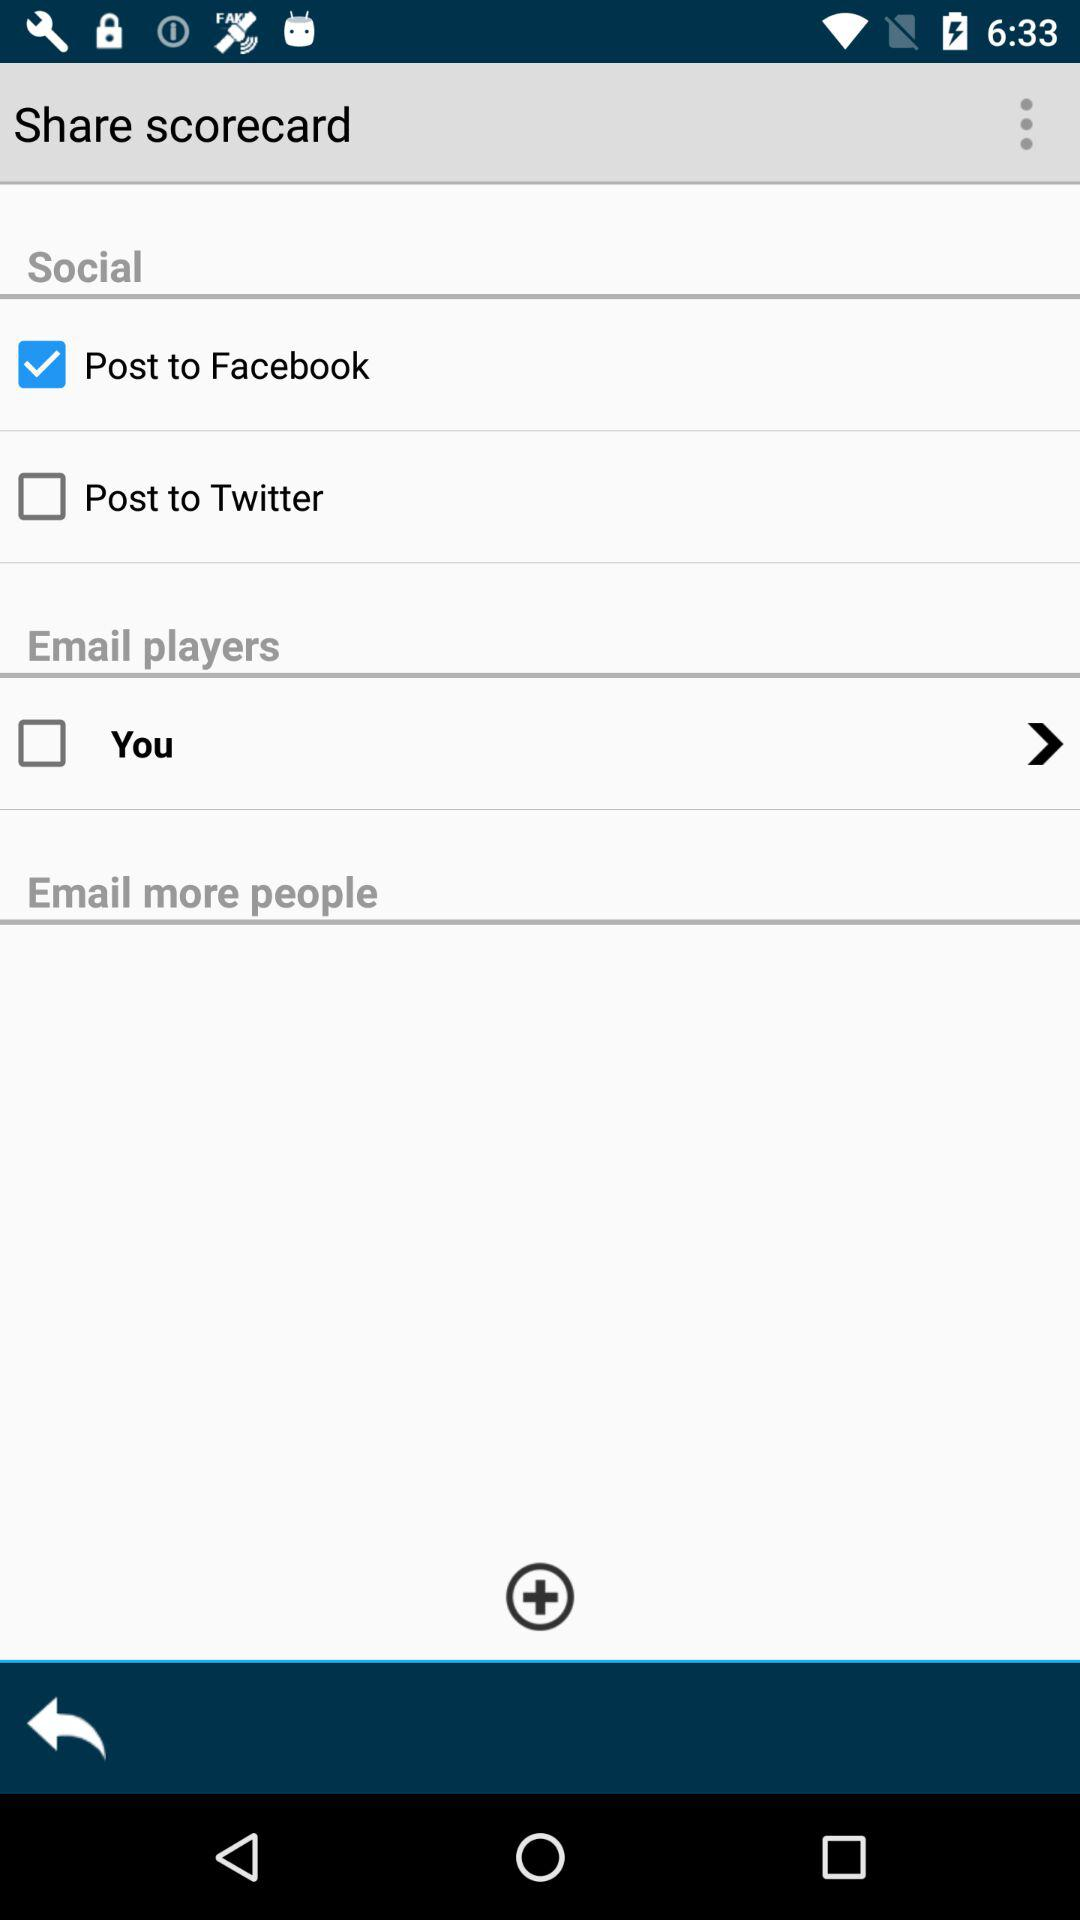How many ways are there to share the scorecard?
Answer the question using a single word or phrase. 3 